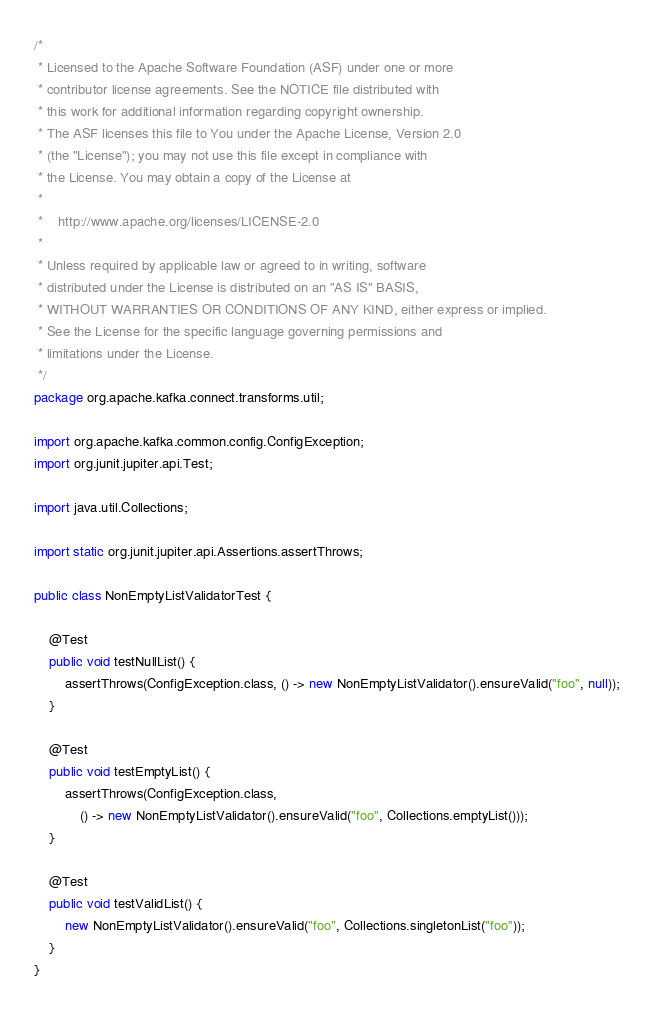Convert code to text. <code><loc_0><loc_0><loc_500><loc_500><_Java_>/*
 * Licensed to the Apache Software Foundation (ASF) under one or more
 * contributor license agreements. See the NOTICE file distributed with
 * this work for additional information regarding copyright ownership.
 * The ASF licenses this file to You under the Apache License, Version 2.0
 * (the "License"); you may not use this file except in compliance with
 * the License. You may obtain a copy of the License at
 *
 *    http://www.apache.org/licenses/LICENSE-2.0
 *
 * Unless required by applicable law or agreed to in writing, software
 * distributed under the License is distributed on an "AS IS" BASIS,
 * WITHOUT WARRANTIES OR CONDITIONS OF ANY KIND, either express or implied.
 * See the License for the specific language governing permissions and
 * limitations under the License.
 */
package org.apache.kafka.connect.transforms.util;

import org.apache.kafka.common.config.ConfigException;
import org.junit.jupiter.api.Test;

import java.util.Collections;

import static org.junit.jupiter.api.Assertions.assertThrows;

public class NonEmptyListValidatorTest {

    @Test
    public void testNullList() {
        assertThrows(ConfigException.class, () -> new NonEmptyListValidator().ensureValid("foo", null));
    }

    @Test
    public void testEmptyList() {
        assertThrows(ConfigException.class,
            () -> new NonEmptyListValidator().ensureValid("foo", Collections.emptyList()));
    }

    @Test
    public void testValidList() {
        new NonEmptyListValidator().ensureValid("foo", Collections.singletonList("foo"));
    }
}
</code> 